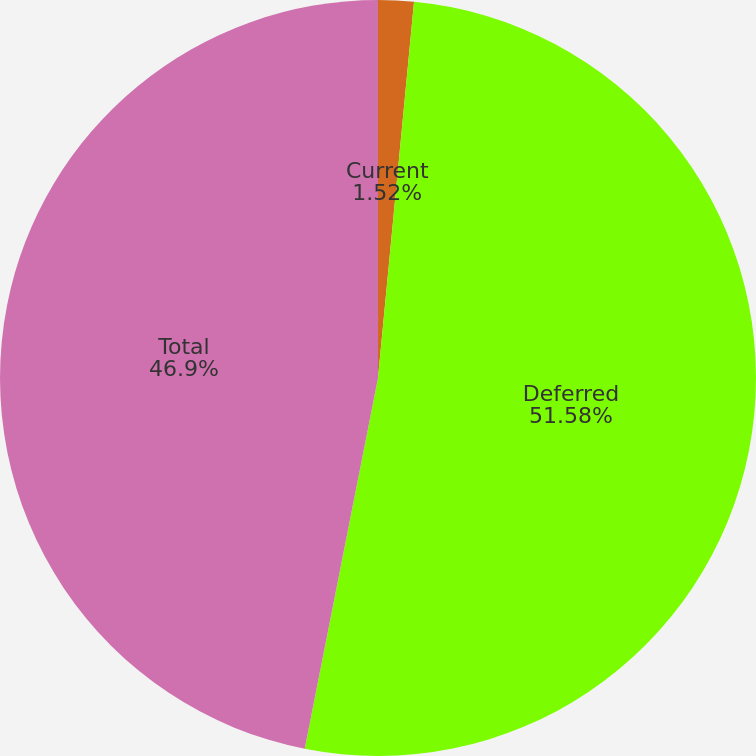Convert chart. <chart><loc_0><loc_0><loc_500><loc_500><pie_chart><fcel>Current<fcel>Deferred<fcel>Total<nl><fcel>1.52%<fcel>51.59%<fcel>46.9%<nl></chart> 